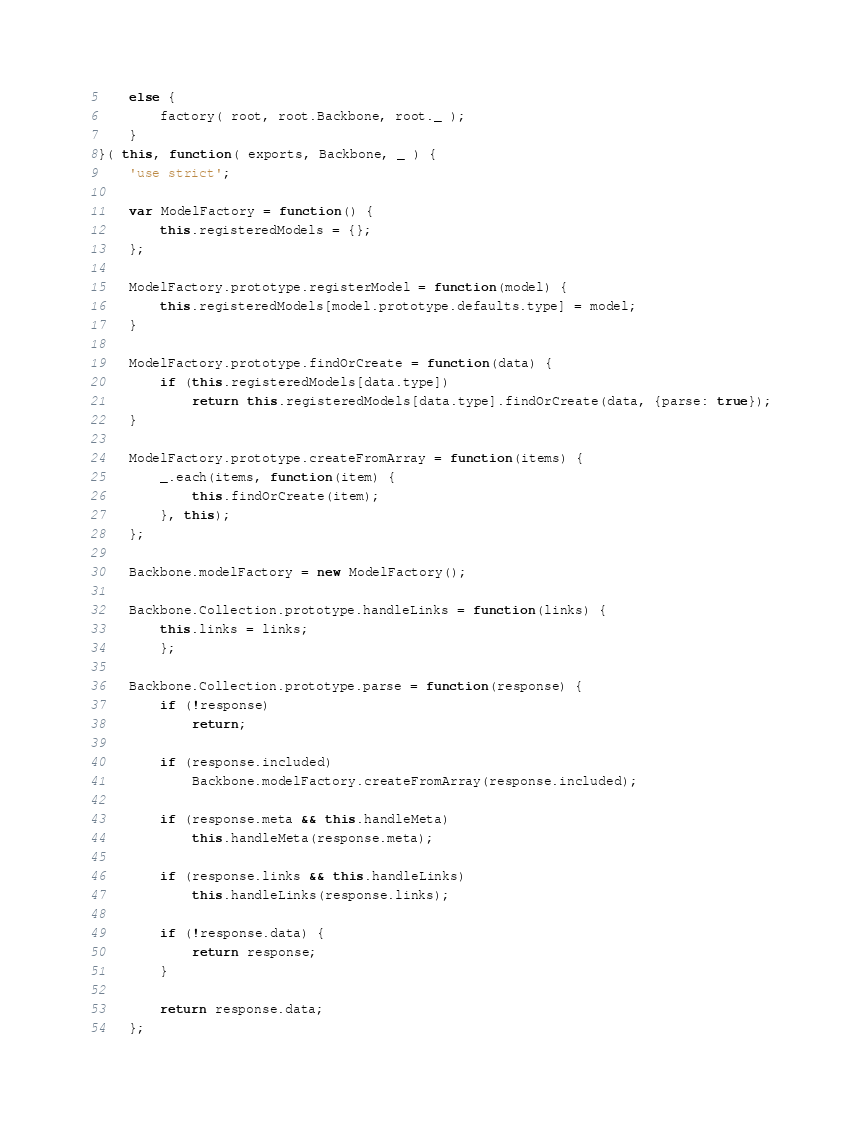Convert code to text. <code><loc_0><loc_0><loc_500><loc_500><_JavaScript_>	else {
		factory( root, root.Backbone, root._ );
	}
}( this, function( exports, Backbone, _ ) {
	'use strict';

	var ModelFactory = function() {
		this.registeredModels = {};
	};

	ModelFactory.prototype.registerModel = function(model) {
		this.registeredModels[model.prototype.defaults.type] = model;
	}

	ModelFactory.prototype.findOrCreate = function(data) {
		if (this.registeredModels[data.type])
			return this.registeredModels[data.type].findOrCreate(data, {parse: true});
	}

	ModelFactory.prototype.createFromArray = function(items) {
		_.each(items, function(item) {
			this.findOrCreate(item);
		}, this);
	};

	Backbone.modelFactory = new ModelFactory();

	Backbone.Collection.prototype.handleLinks = function(links) {
		this.links = links;
		};

	Backbone.Collection.prototype.parse = function(response) {
		if (!response)
			return;

		if (response.included)
			Backbone.modelFactory.createFromArray(response.included);

		if (response.meta && this.handleMeta)
			this.handleMeta(response.meta);

		if (response.links && this.handleLinks)
			this.handleLinks(response.links);

		if (!response.data) {
			return response;
		}

		return response.data;
	};
</code> 